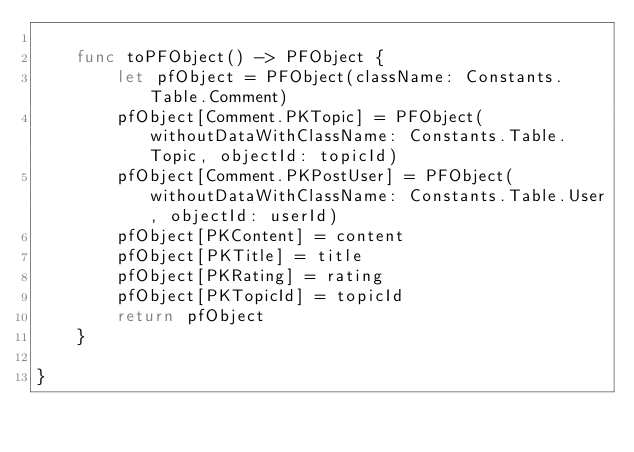<code> <loc_0><loc_0><loc_500><loc_500><_Swift_>    
    func toPFObject() -> PFObject {
        let pfObject = PFObject(className: Constants.Table.Comment)
        pfObject[Comment.PKTopic] = PFObject(withoutDataWithClassName: Constants.Table.Topic, objectId: topicId)
        pfObject[Comment.PKPostUser] = PFObject(withoutDataWithClassName: Constants.Table.User, objectId: userId)
        pfObject[PKContent] = content
        pfObject[PKTitle] = title
        pfObject[PKRating] = rating
        pfObject[PKTopicId] = topicId
        return pfObject
    }
    
}
</code> 